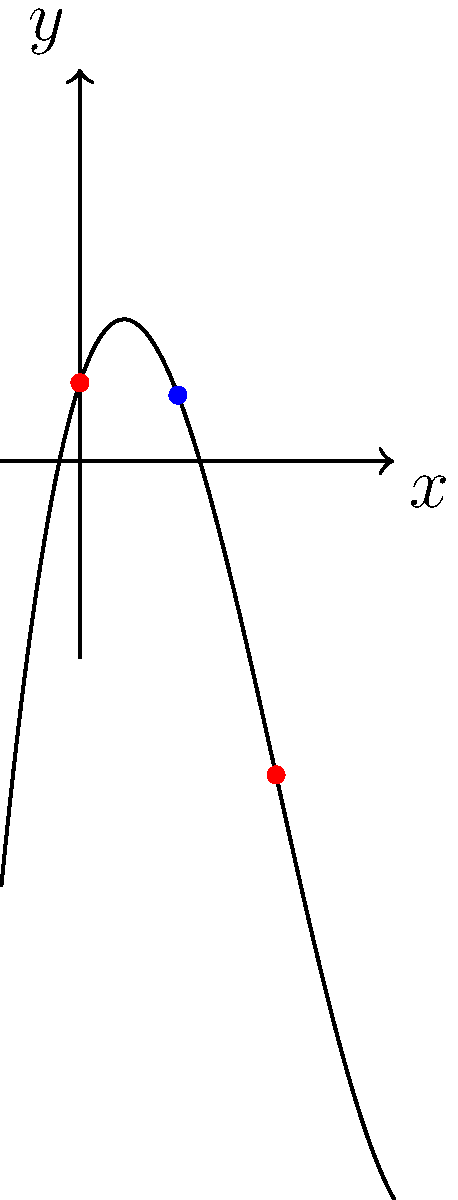As a successful entrepreneur who values precision and efficiency, analyze the cubic function shown in the graph. Identify the number of turning points and inflection points, and determine their x-coordinates. How do these critical points contribute to the overall shape and behavior of the function? Let's approach this systematically:

1) Turning points:
   - These occur where the function changes from increasing to decreasing or vice versa.
   - From the graph, we can see two turning points:
     a) A local maximum at approximately $x = 0$
     b) A local minimum at approximately $x = 5$

2) Inflection point:
   - This occurs where the function changes concavity.
   - From the graph, we can see one inflection point at approximately $x = 2.5$

3) Contribution to function behavior:
   a) The turning points at $x = 0$ and $x = 5$ create the characteristic "S" shape of a cubic function.
   b) The inflection point at $x = 2.5$ marks where the curve changes from concave down to concave up.

4) For a cubic function $f(x) = ax^3 + bx^2 + cx + d$:
   - The derivative $f'(x) = 3ax^2 + 2bx + c$ gives us the turning points when $f'(x) = 0$.
   - The second derivative $f''(x) = 6ax + 2b$ gives us the inflection point when $f''(x) = 0$.

5) These critical points are crucial for understanding the function's behavior:
   - They define the range of the function.
   - They indicate where the function grows fastest or slowest.
   - They help in sketching an accurate representation of the function.
Answer: 2 turning points (x ≈ 0, 5), 1 inflection point (x ≈ 2.5); define S-shape and concavity change. 